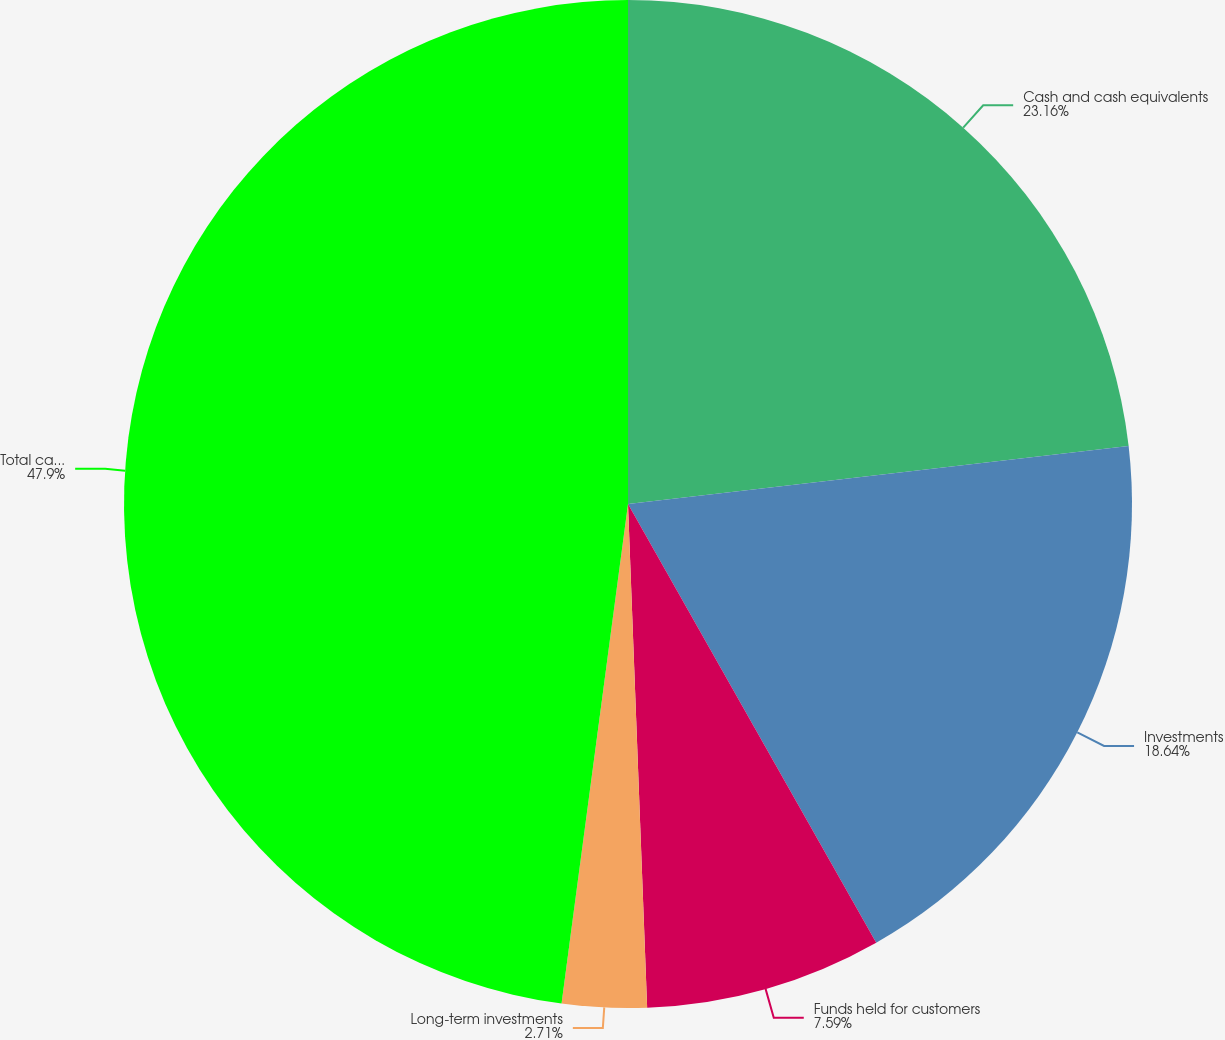Convert chart. <chart><loc_0><loc_0><loc_500><loc_500><pie_chart><fcel>Cash and cash equivalents<fcel>Investments<fcel>Funds held for customers<fcel>Long-term investments<fcel>Total cash and cash<nl><fcel>23.16%<fcel>18.64%<fcel>7.59%<fcel>2.71%<fcel>47.89%<nl></chart> 